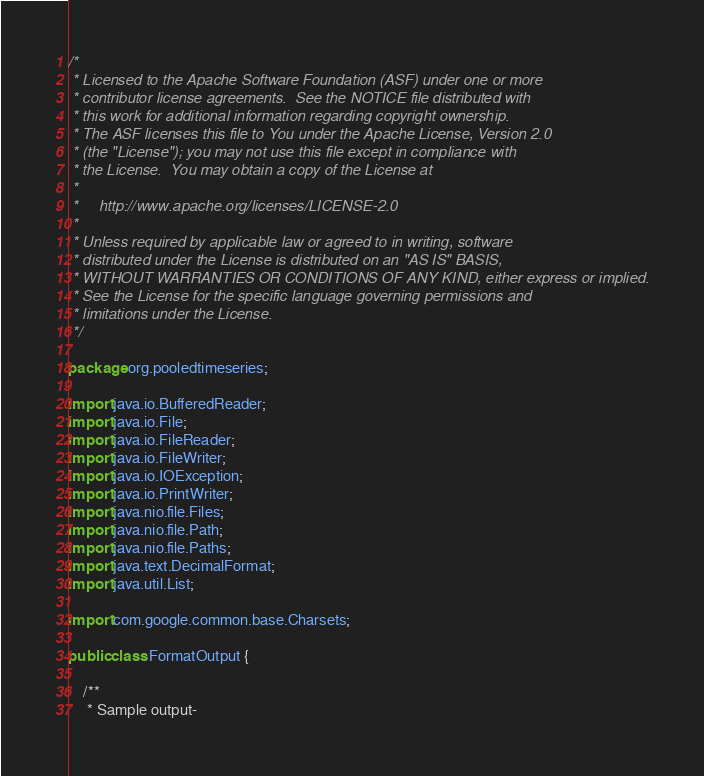<code> <loc_0><loc_0><loc_500><loc_500><_Java_>/*
 * Licensed to the Apache Software Foundation (ASF) under one or more
 * contributor license agreements.  See the NOTICE file distributed with
 * this work for additional information regarding copyright ownership.
 * The ASF licenses this file to You under the Apache License, Version 2.0
 * (the "License"); you may not use this file except in compliance with
 * the License.  You may obtain a copy of the License at
 *
 *     http://www.apache.org/licenses/LICENSE-2.0
 *
 * Unless required by applicable law or agreed to in writing, software
 * distributed under the License is distributed on an "AS IS" BASIS,
 * WITHOUT WARRANTIES OR CONDITIONS OF ANY KIND, either express or implied.
 * See the License for the specific language governing permissions and
 * limitations under the License.
 */

package org.pooledtimeseries;

import java.io.BufferedReader;
import java.io.File;
import java.io.FileReader;
import java.io.FileWriter;
import java.io.IOException;
import java.io.PrintWriter;
import java.nio.file.Files;
import java.nio.file.Path;
import java.nio.file.Paths;
import java.text.DecimalFormat;
import java.util.List;

import com.google.common.base.Charsets;

public class FormatOutput {
	
	/**
	 * Sample output-</code> 